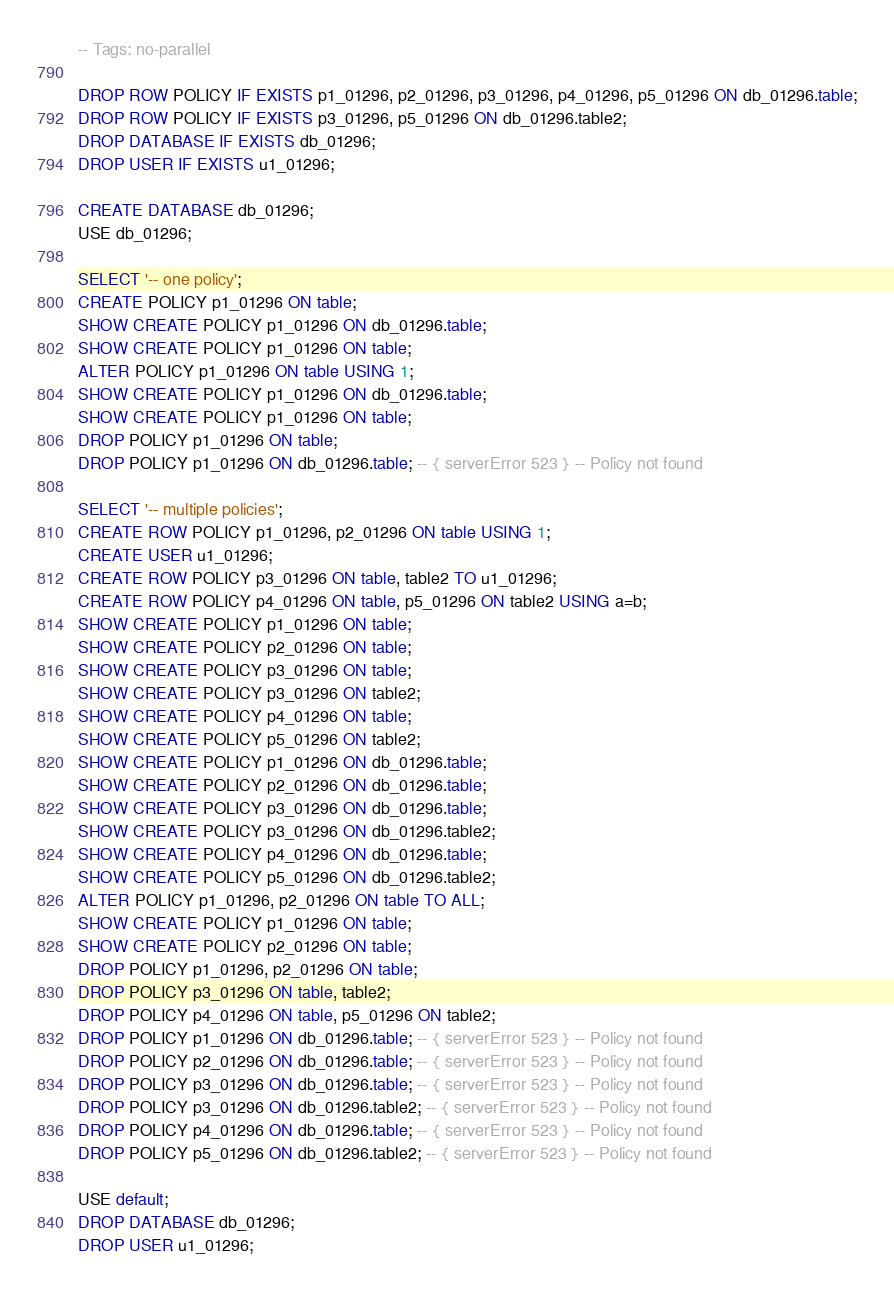<code> <loc_0><loc_0><loc_500><loc_500><_SQL_>-- Tags: no-parallel

DROP ROW POLICY IF EXISTS p1_01296, p2_01296, p3_01296, p4_01296, p5_01296 ON db_01296.table;
DROP ROW POLICY IF EXISTS p3_01296, p5_01296 ON db_01296.table2;
DROP DATABASE IF EXISTS db_01296;
DROP USER IF EXISTS u1_01296;

CREATE DATABASE db_01296;
USE db_01296;

SELECT '-- one policy';
CREATE POLICY p1_01296 ON table;
SHOW CREATE POLICY p1_01296 ON db_01296.table;
SHOW CREATE POLICY p1_01296 ON table;
ALTER POLICY p1_01296 ON table USING 1;
SHOW CREATE POLICY p1_01296 ON db_01296.table;
SHOW CREATE POLICY p1_01296 ON table;
DROP POLICY p1_01296 ON table;
DROP POLICY p1_01296 ON db_01296.table; -- { serverError 523 } -- Policy not found

SELECT '-- multiple policies';
CREATE ROW POLICY p1_01296, p2_01296 ON table USING 1;
CREATE USER u1_01296;
CREATE ROW POLICY p3_01296 ON table, table2 TO u1_01296;
CREATE ROW POLICY p4_01296 ON table, p5_01296 ON table2 USING a=b;
SHOW CREATE POLICY p1_01296 ON table;
SHOW CREATE POLICY p2_01296 ON table;
SHOW CREATE POLICY p3_01296 ON table;
SHOW CREATE POLICY p3_01296 ON table2;
SHOW CREATE POLICY p4_01296 ON table;
SHOW CREATE POLICY p5_01296 ON table2;
SHOW CREATE POLICY p1_01296 ON db_01296.table;
SHOW CREATE POLICY p2_01296 ON db_01296.table;
SHOW CREATE POLICY p3_01296 ON db_01296.table;
SHOW CREATE POLICY p3_01296 ON db_01296.table2;
SHOW CREATE POLICY p4_01296 ON db_01296.table;
SHOW CREATE POLICY p5_01296 ON db_01296.table2;
ALTER POLICY p1_01296, p2_01296 ON table TO ALL;
SHOW CREATE POLICY p1_01296 ON table;
SHOW CREATE POLICY p2_01296 ON table;
DROP POLICY p1_01296, p2_01296 ON table;
DROP POLICY p3_01296 ON table, table2;
DROP POLICY p4_01296 ON table, p5_01296 ON table2;
DROP POLICY p1_01296 ON db_01296.table; -- { serverError 523 } -- Policy not found
DROP POLICY p2_01296 ON db_01296.table; -- { serverError 523 } -- Policy not found
DROP POLICY p3_01296 ON db_01296.table; -- { serverError 523 } -- Policy not found
DROP POLICY p3_01296 ON db_01296.table2; -- { serverError 523 } -- Policy not found
DROP POLICY p4_01296 ON db_01296.table; -- { serverError 523 } -- Policy not found
DROP POLICY p5_01296 ON db_01296.table2; -- { serverError 523 } -- Policy not found

USE default;
DROP DATABASE db_01296;
DROP USER u1_01296;
</code> 